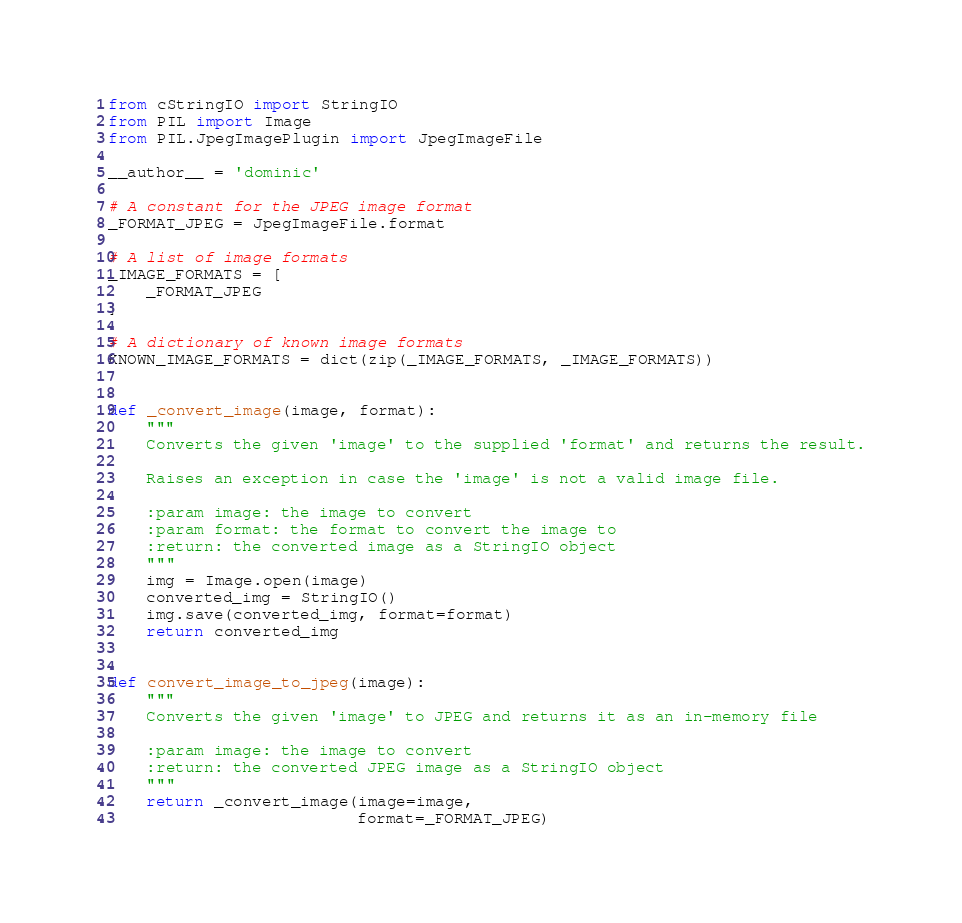<code> <loc_0><loc_0><loc_500><loc_500><_Python_>from cStringIO import StringIO
from PIL import Image
from PIL.JpegImagePlugin import JpegImageFile

__author__ = 'dominic'

# A constant for the JPEG image format
_FORMAT_JPEG = JpegImageFile.format

# A list of image formats
_IMAGE_FORMATS = [
    _FORMAT_JPEG
]

# A dictionary of known image formats
KNOWN_IMAGE_FORMATS = dict(zip(_IMAGE_FORMATS, _IMAGE_FORMATS))


def _convert_image(image, format):
    """
    Converts the given 'image' to the supplied 'format' and returns the result.

    Raises an exception in case the 'image' is not a valid image file.

    :param image: the image to convert
    :param format: the format to convert the image to
    :return: the converted image as a StringIO object
    """
    img = Image.open(image)
    converted_img = StringIO()
    img.save(converted_img, format=format)
    return converted_img


def convert_image_to_jpeg(image):
    """
    Converts the given 'image' to JPEG and returns it as an in-memory file

    :param image: the image to convert
    :return: the converted JPEG image as a StringIO object
    """
    return _convert_image(image=image,
                          format=_FORMAT_JPEG)
</code> 